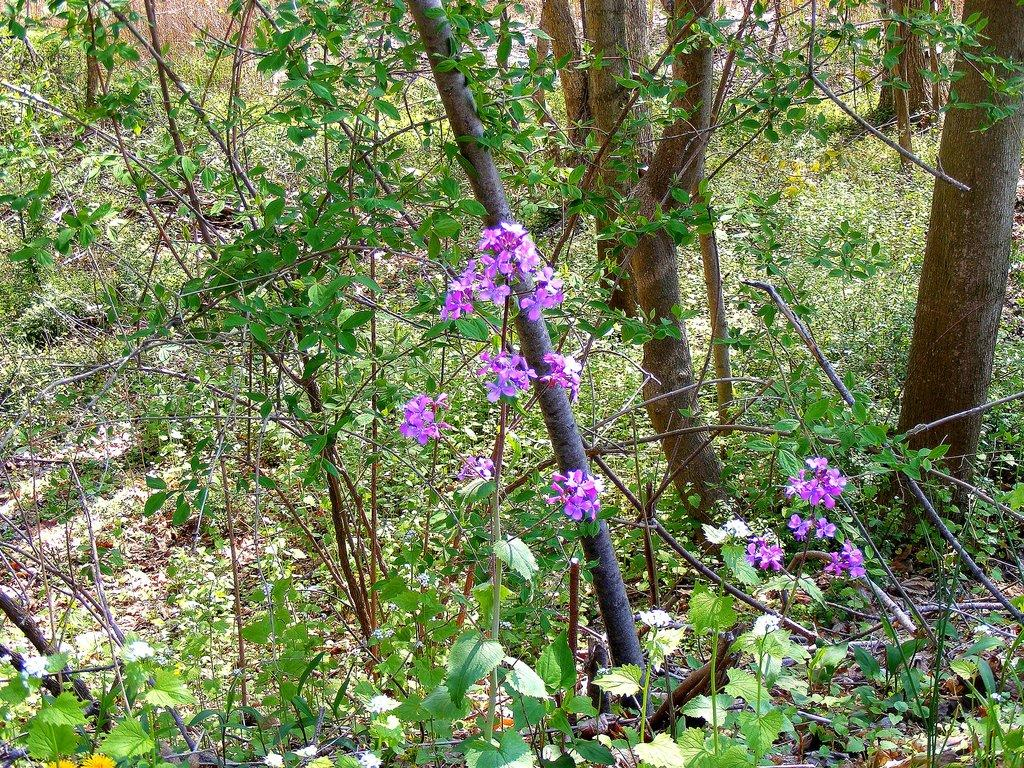What type of vegetation can be seen in the image? There are trees and plants with flowers in the image. What color are the flowers in the image? The flowers are purple in color. What type of knife is used to create the rhythm in the image? There is no knife or rhythm present in the image; it features trees and plants with purple flowers. 